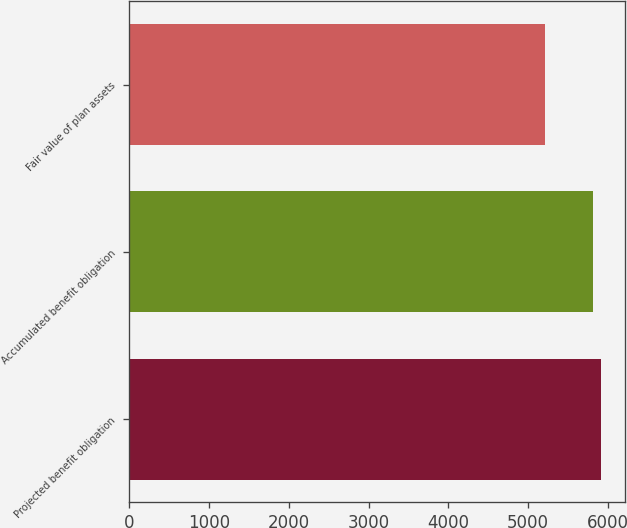Convert chart. <chart><loc_0><loc_0><loc_500><loc_500><bar_chart><fcel>Projected benefit obligation<fcel>Accumulated benefit obligation<fcel>Fair value of plan assets<nl><fcel>5920<fcel>5814<fcel>5214<nl></chart> 